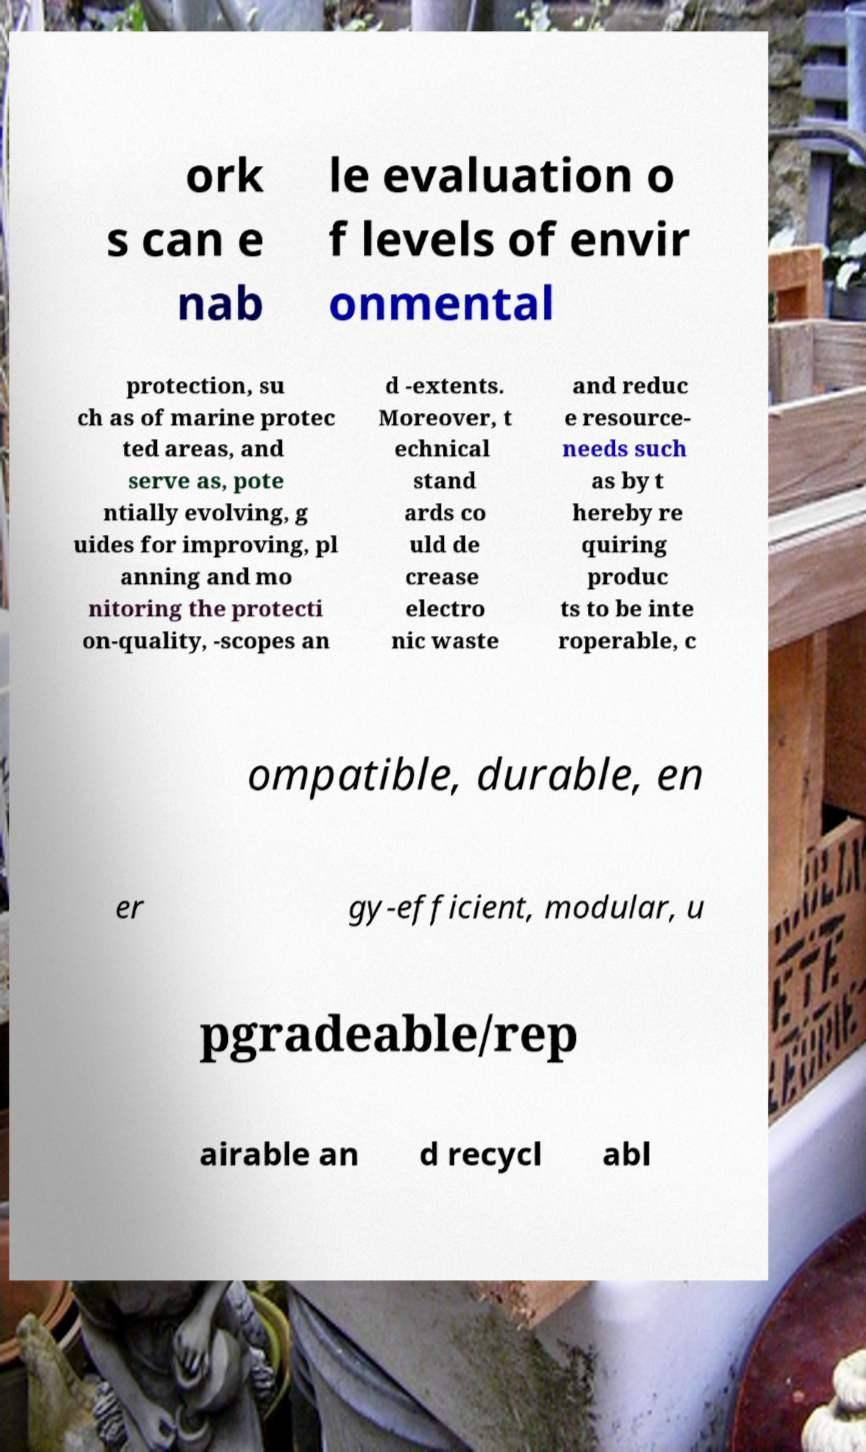For documentation purposes, I need the text within this image transcribed. Could you provide that? ork s can e nab le evaluation o f levels of envir onmental protection, su ch as of marine protec ted areas, and serve as, pote ntially evolving, g uides for improving, pl anning and mo nitoring the protecti on-quality, -scopes an d -extents. Moreover, t echnical stand ards co uld de crease electro nic waste and reduc e resource- needs such as by t hereby re quiring produc ts to be inte roperable, c ompatible, durable, en er gy-efficient, modular, u pgradeable/rep airable an d recycl abl 